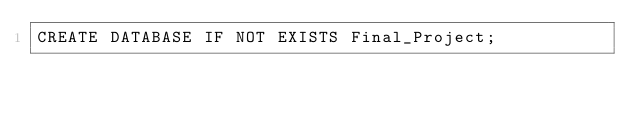Convert code to text. <code><loc_0><loc_0><loc_500><loc_500><_SQL_>CREATE DATABASE IF NOT EXISTS Final_Project;</code> 